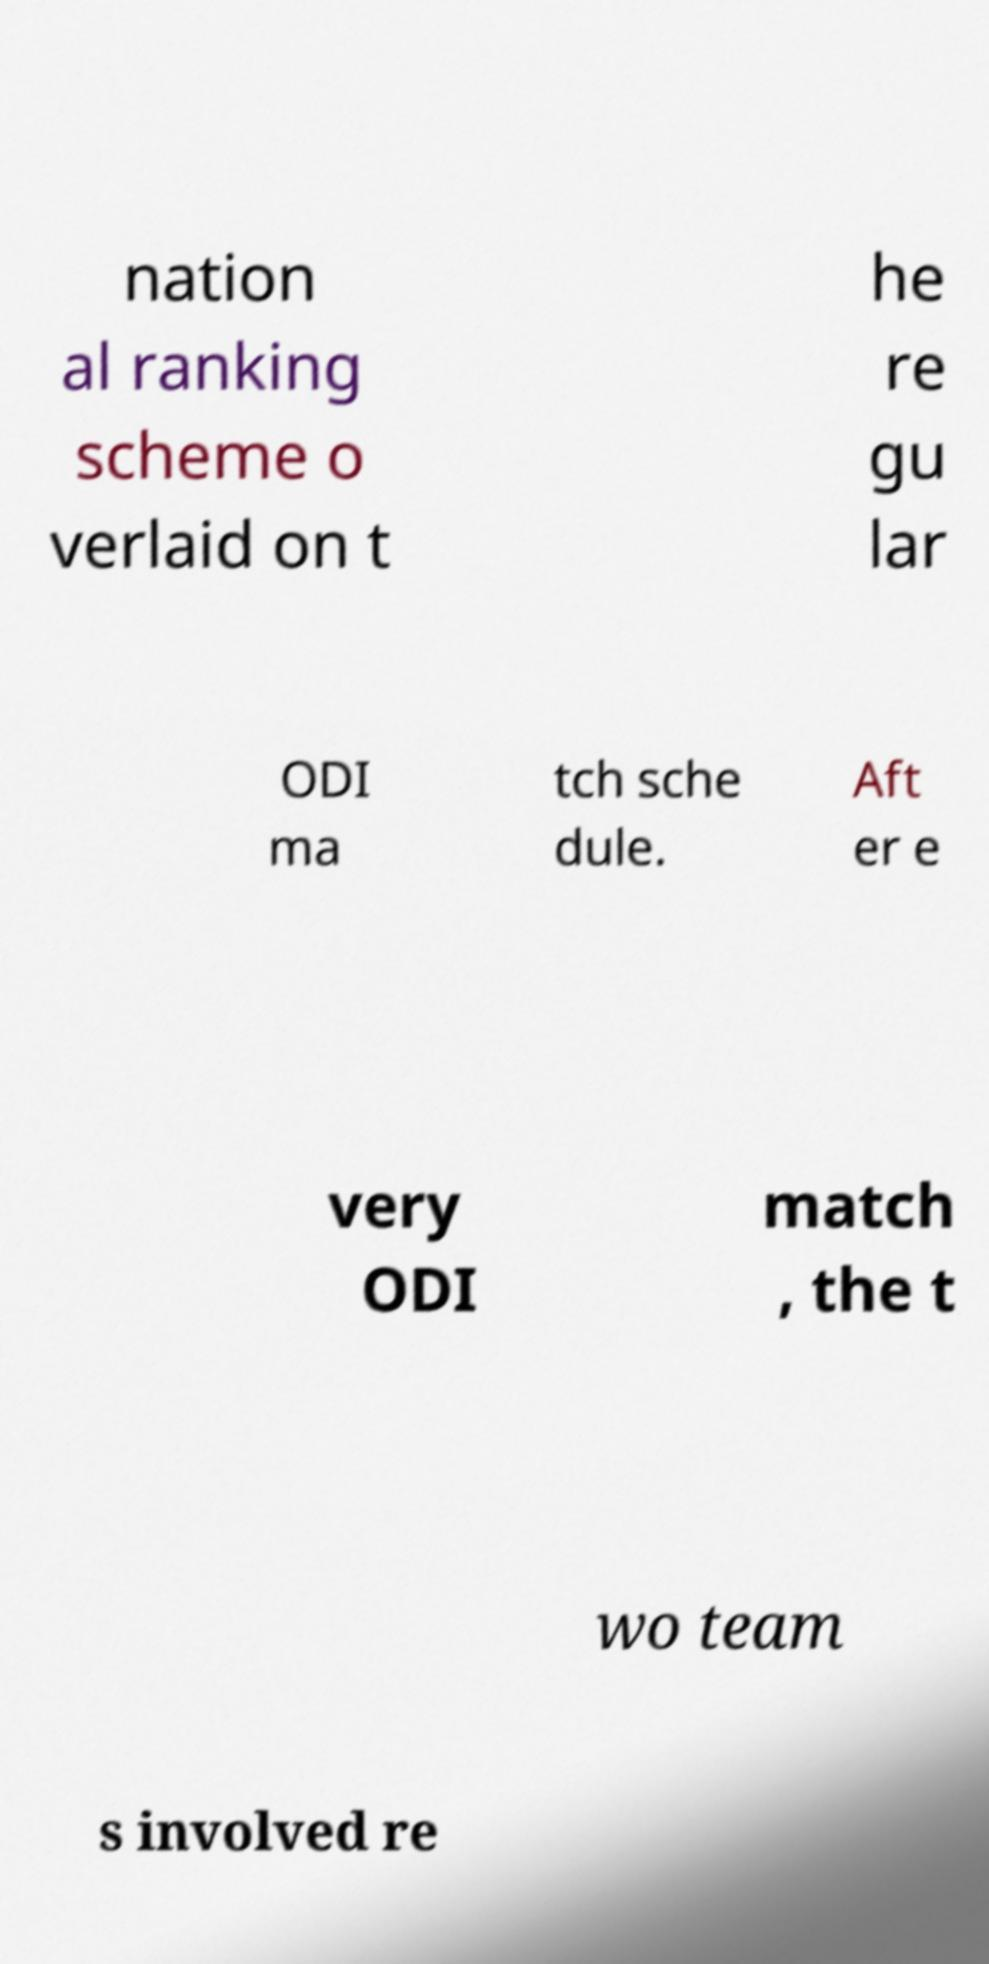For documentation purposes, I need the text within this image transcribed. Could you provide that? nation al ranking scheme o verlaid on t he re gu lar ODI ma tch sche dule. Aft er e very ODI match , the t wo team s involved re 